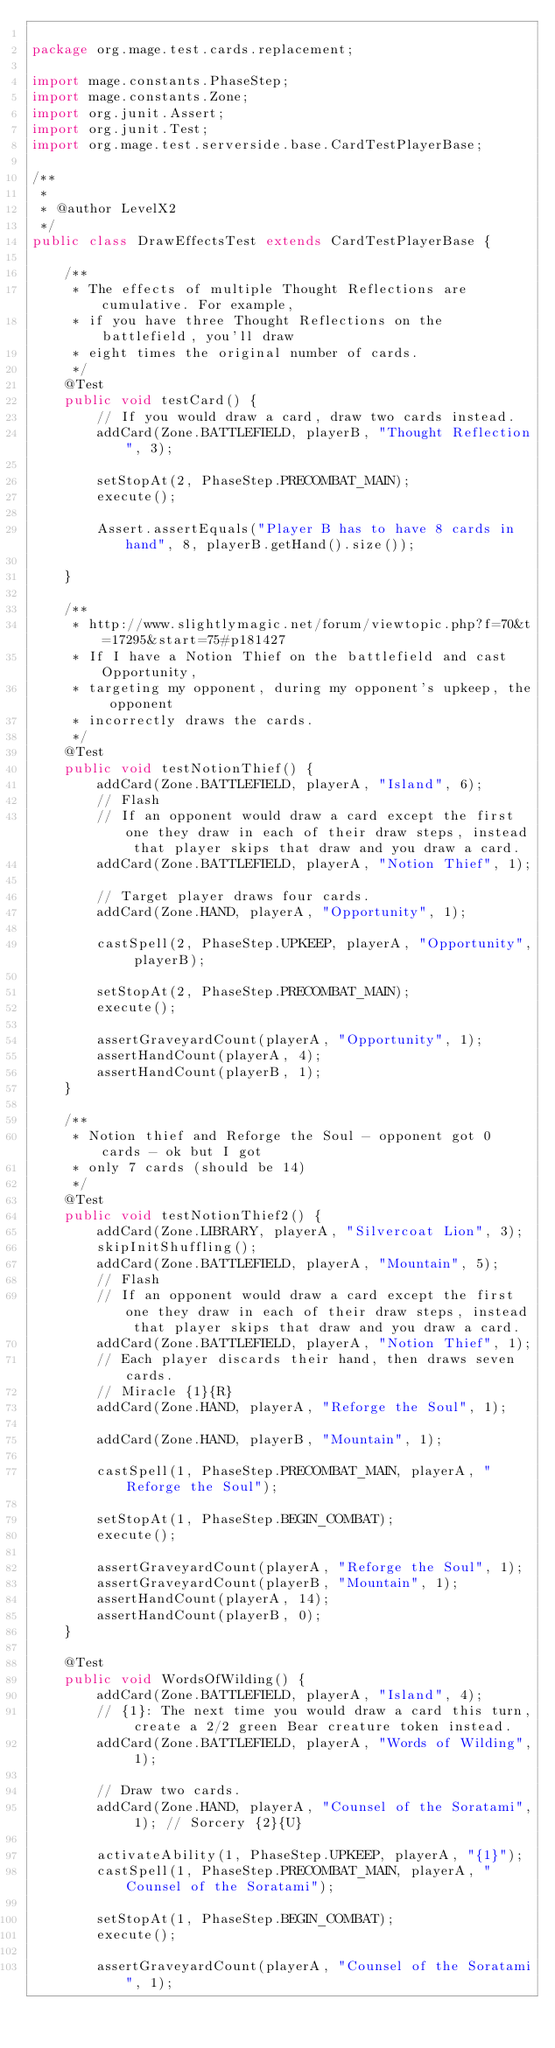Convert code to text. <code><loc_0><loc_0><loc_500><loc_500><_Java_>
package org.mage.test.cards.replacement;

import mage.constants.PhaseStep;
import mage.constants.Zone;
import org.junit.Assert;
import org.junit.Test;
import org.mage.test.serverside.base.CardTestPlayerBase;

/**
 *
 * @author LevelX2
 */
public class DrawEffectsTest extends CardTestPlayerBase {

    /**
     * The effects of multiple Thought Reflections are cumulative. For example,
     * if you have three Thought Reflections on the battlefield, you'll draw
     * eight times the original number of cards.
     */
    @Test
    public void testCard() {
        // If you would draw a card, draw two cards instead.
        addCard(Zone.BATTLEFIELD, playerB, "Thought Reflection", 3);

        setStopAt(2, PhaseStep.PRECOMBAT_MAIN);
        execute();

        Assert.assertEquals("Player B has to have 8 cards in hand", 8, playerB.getHand().size());

    }

    /**
     * http://www.slightlymagic.net/forum/viewtopic.php?f=70&t=17295&start=75#p181427
     * If I have a Notion Thief on the battlefield and cast Opportunity,
     * targeting my opponent, during my opponent's upkeep, the opponent
     * incorrectly draws the cards.
     */
    @Test
    public void testNotionThief() {
        addCard(Zone.BATTLEFIELD, playerA, "Island", 6);
        // Flash
        // If an opponent would draw a card except the first one they draw in each of their draw steps, instead that player skips that draw and you draw a card.
        addCard(Zone.BATTLEFIELD, playerA, "Notion Thief", 1);

        // Target player draws four cards.
        addCard(Zone.HAND, playerA, "Opportunity", 1);

        castSpell(2, PhaseStep.UPKEEP, playerA, "Opportunity", playerB);

        setStopAt(2, PhaseStep.PRECOMBAT_MAIN);
        execute();

        assertGraveyardCount(playerA, "Opportunity", 1);
        assertHandCount(playerA, 4);
        assertHandCount(playerB, 1);
    }

    /**
     * Notion thief and Reforge the Soul - opponent got 0 cards - ok but I got
     * only 7 cards (should be 14)
     */
    @Test
    public void testNotionThief2() {
        addCard(Zone.LIBRARY, playerA, "Silvercoat Lion", 3);
        skipInitShuffling();
        addCard(Zone.BATTLEFIELD, playerA, "Mountain", 5);
        // Flash
        // If an opponent would draw a card except the first one they draw in each of their draw steps, instead that player skips that draw and you draw a card.
        addCard(Zone.BATTLEFIELD, playerA, "Notion Thief", 1);
        // Each player discards their hand, then draws seven cards.
        // Miracle {1}{R}
        addCard(Zone.HAND, playerA, "Reforge the Soul", 1);

        addCard(Zone.HAND, playerB, "Mountain", 1);

        castSpell(1, PhaseStep.PRECOMBAT_MAIN, playerA, "Reforge the Soul");

        setStopAt(1, PhaseStep.BEGIN_COMBAT);
        execute();

        assertGraveyardCount(playerA, "Reforge the Soul", 1);
        assertGraveyardCount(playerB, "Mountain", 1);
        assertHandCount(playerA, 14);
        assertHandCount(playerB, 0);
    }

    @Test
    public void WordsOfWilding() {
        addCard(Zone.BATTLEFIELD, playerA, "Island", 4);
        // {1}: The next time you would draw a card this turn, create a 2/2 green Bear creature token instead.
        addCard(Zone.BATTLEFIELD, playerA, "Words of Wilding", 1);

        // Draw two cards.
        addCard(Zone.HAND, playerA, "Counsel of the Soratami", 1); // Sorcery {2}{U}

        activateAbility(1, PhaseStep.UPKEEP, playerA, "{1}");
        castSpell(1, PhaseStep.PRECOMBAT_MAIN, playerA, "Counsel of the Soratami");

        setStopAt(1, PhaseStep.BEGIN_COMBAT);
        execute();

        assertGraveyardCount(playerA, "Counsel of the Soratami", 1);</code> 